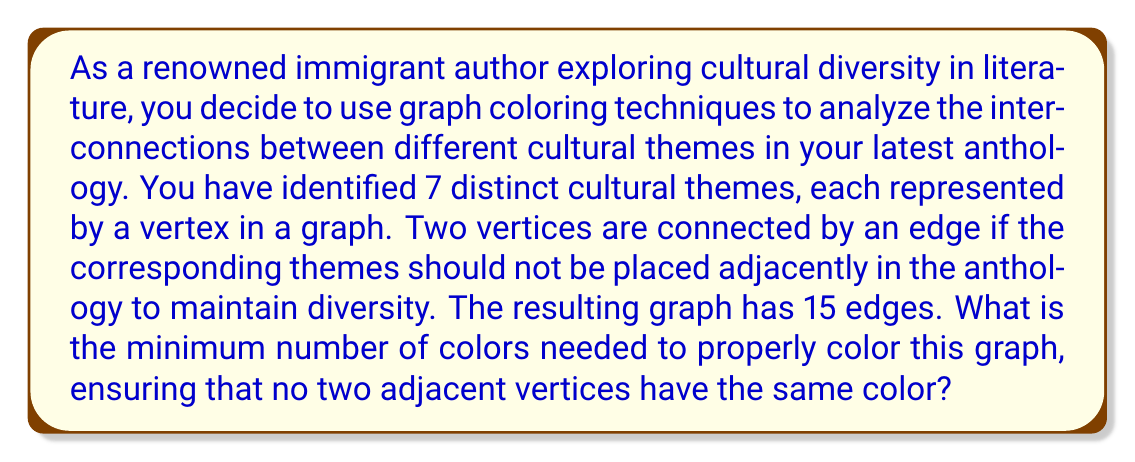Teach me how to tackle this problem. To solve this problem, we'll use the following steps:

1) First, recall that the chromatic number of a graph is the minimum number of colors needed to color the graph such that no two adjacent vertices have the same color.

2) We can use Brooks' theorem to get an upper bound on the chromatic number. Brooks' theorem states that for a connected graph G that is neither a complete graph nor an odd cycle, the chromatic number is at most the maximum degree of the graph.

3) To find the maximum degree, we can use the handshaking lemma:

   $$2|E| = \sum_{v \in V} \deg(v)$$

   where $|E|$ is the number of edges, $|V|$ is the number of vertices, and $\deg(v)$ is the degree of vertex $v$.

4) In this case, $|E| = 15$ and $|V| = 7$. So:

   $$2(15) = 30 = \sum_{v \in V} \deg(v)$$

5) The maximum possible degree occurs when one vertex is connected to all others. In this case, the maximum degree would be 6.

6) However, if one vertex had degree 6, the sum of all degrees would be at least $6 + 6 = 12$ (as each of those 6 edges contributes 1 to the degree of another vertex). The remaining degree sum (18) would be distributed among 5 vertices, meaning at least one other vertex would have degree 4 or more.

7) Therefore, the maximum degree in this graph is at most 5.

8) By Brooks' theorem, the chromatic number is at most 5, unless the graph is a complete graph or an odd cycle.

9) It's not a complete graph (which would have $\binom{7}{2} = 21$ edges), and it's not an odd cycle (which would have 7 edges for 7 vertices).

10) Therefore, the chromatic number is at most 5.

11) Without more information about the specific structure of the graph, we can't determine if a lower number of colors is possible. So 5 is our best upper bound.
Answer: The minimum number of colors needed is at most 5. 